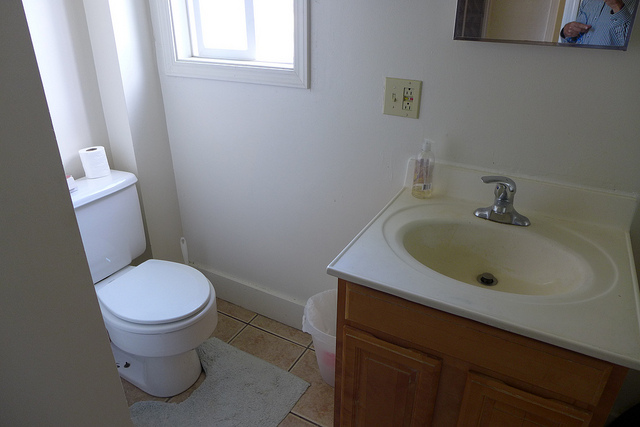What items are on the sink? On the sink, there appears to be a single bottle of liquid soap. 